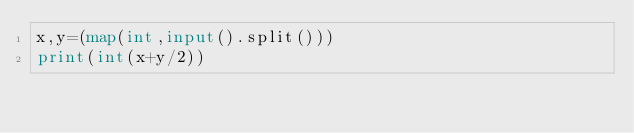Convert code to text. <code><loc_0><loc_0><loc_500><loc_500><_Python_>x,y=(map(int,input().split()))
print(int(x+y/2))</code> 